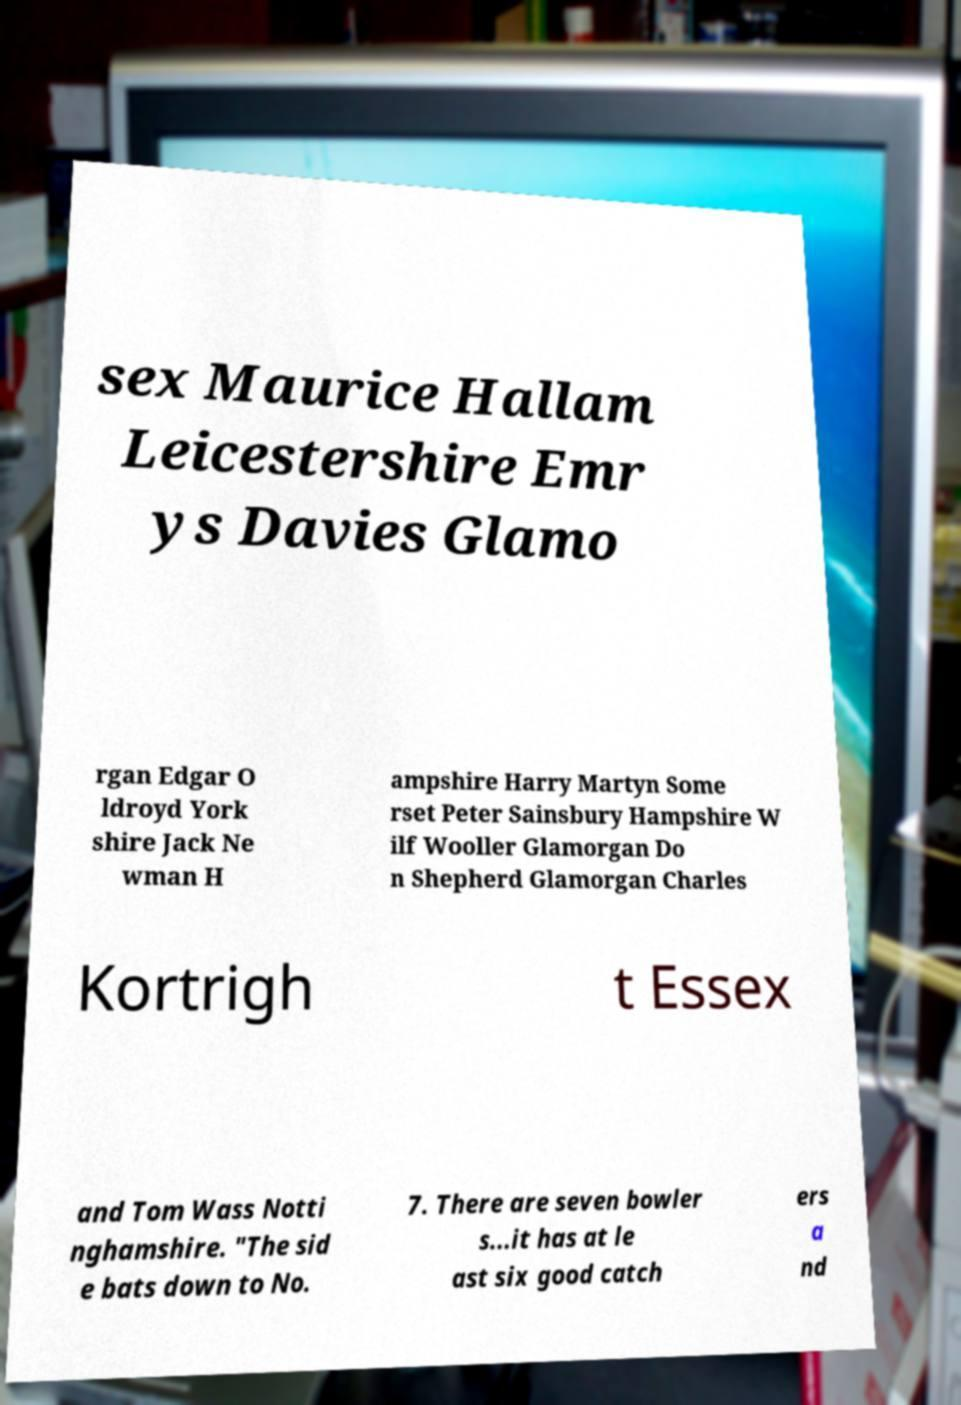Can you read and provide the text displayed in the image?This photo seems to have some interesting text. Can you extract and type it out for me? sex Maurice Hallam Leicestershire Emr ys Davies Glamo rgan Edgar O ldroyd York shire Jack Ne wman H ampshire Harry Martyn Some rset Peter Sainsbury Hampshire W ilf Wooller Glamorgan Do n Shepherd Glamorgan Charles Kortrigh t Essex and Tom Wass Notti nghamshire. "The sid e bats down to No. 7. There are seven bowler s...it has at le ast six good catch ers a nd 